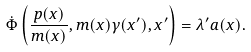<formula> <loc_0><loc_0><loc_500><loc_500>\dot { \Phi } \left ( \frac { p ( x ) } { m ( x ) } , m ( x ) \gamma ( x ^ { \prime } ) , x ^ { \prime } \right ) = \lambda ^ { \prime } a ( x ) .</formula> 